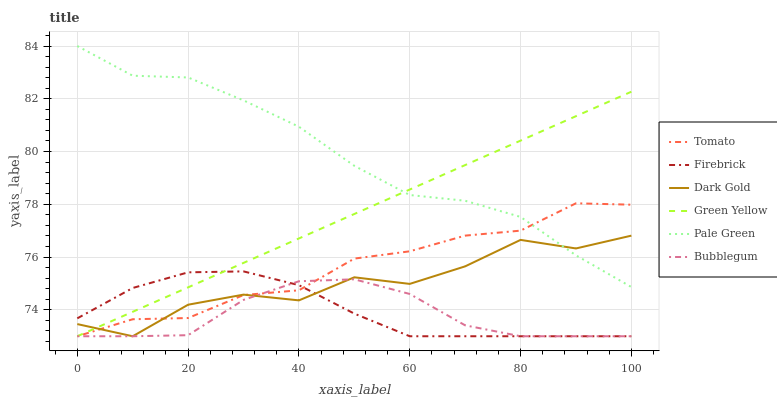Does Bubblegum have the minimum area under the curve?
Answer yes or no. Yes. Does Pale Green have the maximum area under the curve?
Answer yes or no. Yes. Does Dark Gold have the minimum area under the curve?
Answer yes or no. No. Does Dark Gold have the maximum area under the curve?
Answer yes or no. No. Is Green Yellow the smoothest?
Answer yes or no. Yes. Is Dark Gold the roughest?
Answer yes or no. Yes. Is Firebrick the smoothest?
Answer yes or no. No. Is Firebrick the roughest?
Answer yes or no. No. Does Tomato have the lowest value?
Answer yes or no. Yes. Does Pale Green have the lowest value?
Answer yes or no. No. Does Pale Green have the highest value?
Answer yes or no. Yes. Does Dark Gold have the highest value?
Answer yes or no. No. Is Bubblegum less than Pale Green?
Answer yes or no. Yes. Is Pale Green greater than Firebrick?
Answer yes or no. Yes. Does Tomato intersect Firebrick?
Answer yes or no. Yes. Is Tomato less than Firebrick?
Answer yes or no. No. Is Tomato greater than Firebrick?
Answer yes or no. No. Does Bubblegum intersect Pale Green?
Answer yes or no. No. 